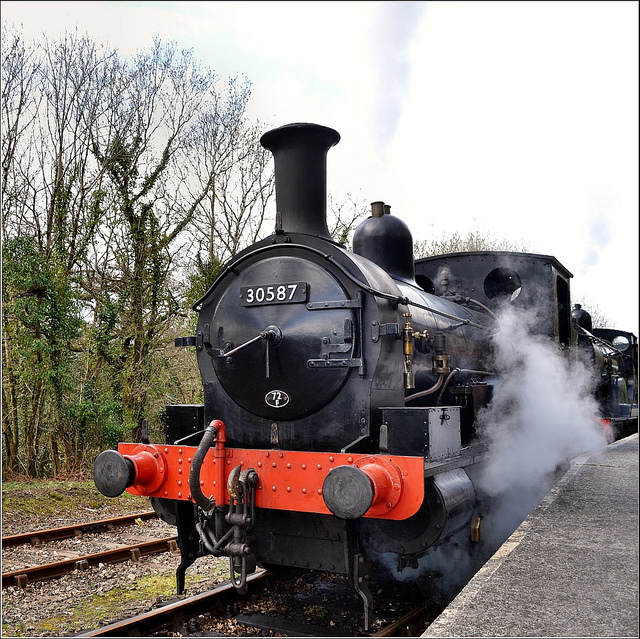Please transcribe the text information in this image. 30587 72 